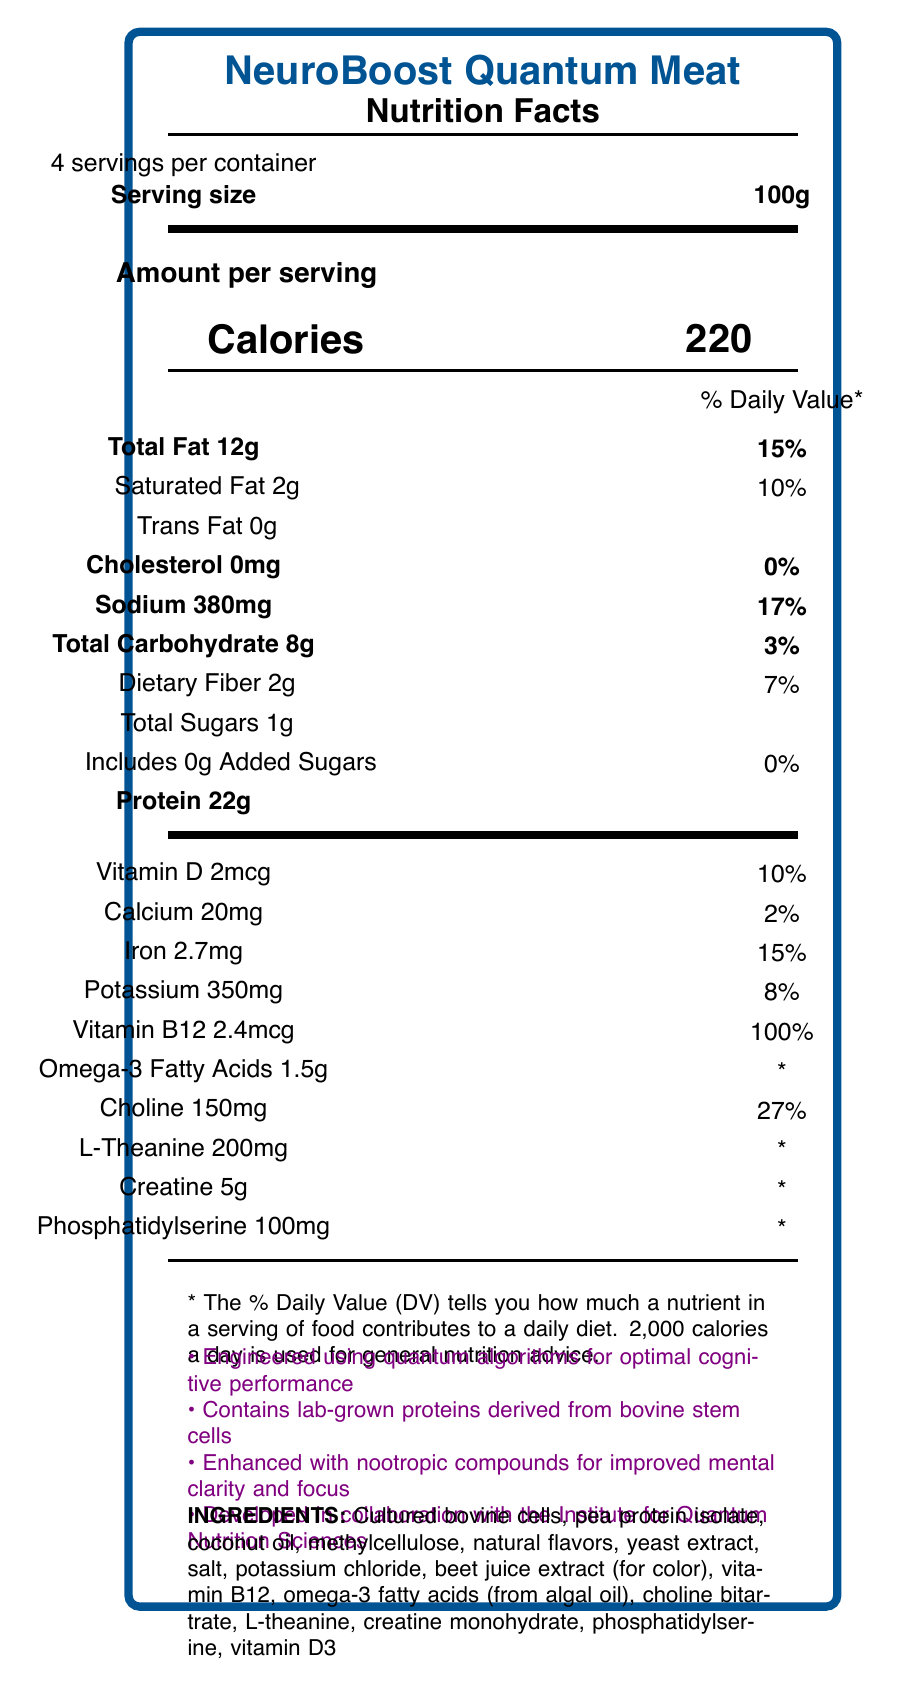what is the serving size? The serving size is clearly listed as 100g at the top of the Nutrition Facts Label.
Answer: 100g how many calories are there per serving? The number of calories per serving is stated as 220 in the section labeled "Calories."
Answer: 220 what is the total amount of protein per serving? The amount of protein per serving is stated as 22g under the protein section.
Answer: 22g what percentage of daily value does sodium provide? The sodium content provides 17% of the daily value according to the label.
Answer: 17% how much vitamin B12 is in each serving, and what percent does it fulfill of the daily value? Each serving contains 2.4mcg of vitamin B12, which fulfills 100% of the daily value.
Answer: 2.4mcg, 100% which ingredient is used for color? The beet juice extract is listed as the ingredient used for color in the ingredients list.
Answer: Beet juice extract what is the main source of omega-3 fatty acids in this product? Omega-3 fatty acids are derived from algal oil, as mentioned in the ingredients section.
Answer: Algal oil how many servings are there per container? The label states that there are 4 servings per container.
Answer: 4 how much creatine is in each serving? A. 200mg B. 5g C. 100mg D. 1.5g The label lists 5g as the amount of creatine per serving.
Answer: B what is the total amount of carbohydrate in each serving? A. 10g B. 8g C. 12g D. 2g The label states that the total carbohydrate per serving is 8g.
Answer: B true or false: The product contains added sugars. The label clearly states that the product includes 0g of added sugars.
Answer: False describe the main idea of the document. The description includes serving size, number of servings per container, and specific nutrient contents such as calories, proteins, fats, vitamins, and minerals. Special features like its lab-grown origin and cognitive enhancements are also highlighted at the bottom of the label.
Answer: The document is a Nutrition Facts Label for NeuroBoost Quantum Meat, a lab-grown meat alternative optimized for cognitive performance. It details the nutrient content per serving, including calories, fats, proteins, vitamins, and other ingredients, while highlighting its special enhancements for mental clarity and focus. how much dietary fiber does a serving contain? The label lists the dietary fiber content per serving as 2g.
Answer: 2g is the source of protein lab-grown or plant-based? The additional information section states that the product contains lab-grown proteins derived from bovine stem cells.
Answer: The source of protein is lab-grown. what is the total fat content and its percentage of daily value per serving? The total fat content per serving is 12g, which is 15% of the daily value.
Answer: 12g, 15% can you determine the exact formula used in the quantum algorithms for optimizing cognitive performance from this label? The document mentions that the product is engineered using quantum algorithms for optimal cognitive performance, but does not provide the exact formula or details of these algorithms.
Answer: Cannot be determined 